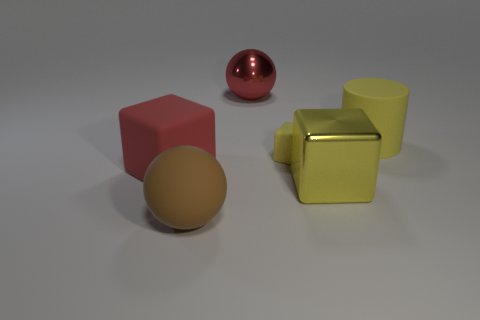How many cubes are left of the red shiny thing that is behind the large matte cube?
Keep it short and to the point. 1. How many balls are either big yellow matte objects or yellow matte things?
Provide a short and direct response. 0. Are there any brown rubber balls?
Ensure brevity in your answer.  Yes. What is the size of the yellow matte object that is the same shape as the yellow shiny thing?
Your response must be concise. Small. What is the shape of the big red thing that is in front of the large shiny object that is on the left side of the tiny block?
Ensure brevity in your answer.  Cube. How many yellow things are either small rubber objects or big cubes?
Give a very brief answer. 2. The shiny cube is what color?
Keep it short and to the point. Yellow. Do the red matte object and the brown rubber object have the same size?
Offer a very short reply. Yes. Is there any other thing that has the same shape as the brown thing?
Your answer should be very brief. Yes. Is the material of the large brown sphere the same as the large block in front of the big rubber cube?
Your response must be concise. No. 